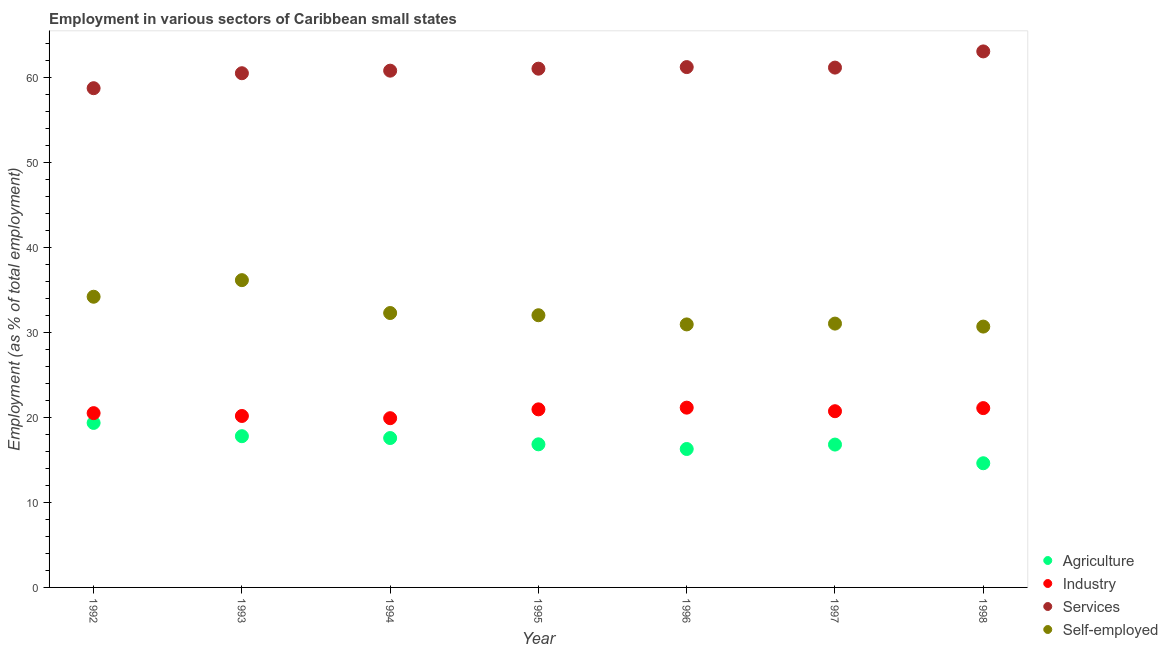How many different coloured dotlines are there?
Ensure brevity in your answer.  4. What is the percentage of workers in services in 1992?
Give a very brief answer. 58.79. Across all years, what is the maximum percentage of workers in industry?
Offer a very short reply. 21.17. Across all years, what is the minimum percentage of self employed workers?
Give a very brief answer. 30.72. What is the total percentage of workers in industry in the graph?
Offer a very short reply. 144.65. What is the difference between the percentage of workers in agriculture in 1993 and that in 1995?
Your response must be concise. 0.96. What is the difference between the percentage of self employed workers in 1994 and the percentage of workers in industry in 1992?
Provide a short and direct response. 11.79. What is the average percentage of workers in services per year?
Keep it short and to the point. 60.98. In the year 1994, what is the difference between the percentage of self employed workers and percentage of workers in agriculture?
Your answer should be compact. 14.72. What is the ratio of the percentage of workers in services in 1992 to that in 1994?
Provide a short and direct response. 0.97. What is the difference between the highest and the second highest percentage of workers in services?
Your response must be concise. 1.85. What is the difference between the highest and the lowest percentage of workers in agriculture?
Offer a terse response. 4.75. In how many years, is the percentage of workers in services greater than the average percentage of workers in services taken over all years?
Provide a short and direct response. 4. Is the sum of the percentage of workers in agriculture in 1995 and 1998 greater than the maximum percentage of workers in industry across all years?
Your answer should be compact. Yes. Is it the case that in every year, the sum of the percentage of workers in services and percentage of workers in industry is greater than the sum of percentage of self employed workers and percentage of workers in agriculture?
Keep it short and to the point. No. Is it the case that in every year, the sum of the percentage of workers in agriculture and percentage of workers in industry is greater than the percentage of workers in services?
Keep it short and to the point. No. Does the percentage of workers in agriculture monotonically increase over the years?
Ensure brevity in your answer.  No. Is the percentage of workers in agriculture strictly greater than the percentage of workers in industry over the years?
Your answer should be compact. No. What is the difference between two consecutive major ticks on the Y-axis?
Offer a very short reply. 10. Does the graph contain grids?
Make the answer very short. No. How many legend labels are there?
Offer a terse response. 4. What is the title of the graph?
Your answer should be very brief. Employment in various sectors of Caribbean small states. Does "International Monetary Fund" appear as one of the legend labels in the graph?
Provide a succinct answer. No. What is the label or title of the Y-axis?
Ensure brevity in your answer.  Employment (as % of total employment). What is the Employment (as % of total employment) in Agriculture in 1992?
Offer a very short reply. 19.37. What is the Employment (as % of total employment) in Industry in 1992?
Provide a short and direct response. 20.52. What is the Employment (as % of total employment) in Services in 1992?
Give a very brief answer. 58.79. What is the Employment (as % of total employment) of Self-employed in 1992?
Your answer should be very brief. 34.23. What is the Employment (as % of total employment) of Agriculture in 1993?
Keep it short and to the point. 17.81. What is the Employment (as % of total employment) in Industry in 1993?
Provide a short and direct response. 20.19. What is the Employment (as % of total employment) of Services in 1993?
Provide a short and direct response. 60.55. What is the Employment (as % of total employment) in Self-employed in 1993?
Give a very brief answer. 36.19. What is the Employment (as % of total employment) in Agriculture in 1994?
Your answer should be compact. 17.59. What is the Employment (as % of total employment) of Industry in 1994?
Give a very brief answer. 19.93. What is the Employment (as % of total employment) in Services in 1994?
Offer a very short reply. 60.85. What is the Employment (as % of total employment) in Self-employed in 1994?
Make the answer very short. 32.31. What is the Employment (as % of total employment) of Agriculture in 1995?
Your answer should be very brief. 16.85. What is the Employment (as % of total employment) of Industry in 1995?
Offer a terse response. 20.97. What is the Employment (as % of total employment) of Services in 1995?
Provide a short and direct response. 61.09. What is the Employment (as % of total employment) of Self-employed in 1995?
Provide a short and direct response. 32.05. What is the Employment (as % of total employment) of Agriculture in 1996?
Provide a succinct answer. 16.3. What is the Employment (as % of total employment) in Industry in 1996?
Your answer should be compact. 21.17. What is the Employment (as % of total employment) of Services in 1996?
Provide a succinct answer. 61.27. What is the Employment (as % of total employment) of Self-employed in 1996?
Your answer should be compact. 30.97. What is the Employment (as % of total employment) of Agriculture in 1997?
Provide a succinct answer. 16.82. What is the Employment (as % of total employment) of Industry in 1997?
Offer a terse response. 20.75. What is the Employment (as % of total employment) in Services in 1997?
Ensure brevity in your answer.  61.22. What is the Employment (as % of total employment) of Self-employed in 1997?
Keep it short and to the point. 31.07. What is the Employment (as % of total employment) in Agriculture in 1998?
Provide a short and direct response. 14.62. What is the Employment (as % of total employment) of Industry in 1998?
Your answer should be compact. 21.12. What is the Employment (as % of total employment) in Services in 1998?
Your answer should be compact. 63.12. What is the Employment (as % of total employment) in Self-employed in 1998?
Your answer should be very brief. 30.72. Across all years, what is the maximum Employment (as % of total employment) in Agriculture?
Make the answer very short. 19.37. Across all years, what is the maximum Employment (as % of total employment) in Industry?
Your answer should be very brief. 21.17. Across all years, what is the maximum Employment (as % of total employment) in Services?
Your answer should be compact. 63.12. Across all years, what is the maximum Employment (as % of total employment) of Self-employed?
Keep it short and to the point. 36.19. Across all years, what is the minimum Employment (as % of total employment) of Agriculture?
Offer a terse response. 14.62. Across all years, what is the minimum Employment (as % of total employment) of Industry?
Ensure brevity in your answer.  19.93. Across all years, what is the minimum Employment (as % of total employment) in Services?
Your answer should be very brief. 58.79. Across all years, what is the minimum Employment (as % of total employment) in Self-employed?
Your answer should be very brief. 30.72. What is the total Employment (as % of total employment) in Agriculture in the graph?
Make the answer very short. 119.38. What is the total Employment (as % of total employment) of Industry in the graph?
Provide a succinct answer. 144.65. What is the total Employment (as % of total employment) in Services in the graph?
Provide a succinct answer. 426.89. What is the total Employment (as % of total employment) in Self-employed in the graph?
Provide a succinct answer. 227.54. What is the difference between the Employment (as % of total employment) in Agriculture in 1992 and that in 1993?
Your answer should be very brief. 1.56. What is the difference between the Employment (as % of total employment) in Industry in 1992 and that in 1993?
Provide a short and direct response. 0.33. What is the difference between the Employment (as % of total employment) in Services in 1992 and that in 1993?
Your answer should be very brief. -1.76. What is the difference between the Employment (as % of total employment) in Self-employed in 1992 and that in 1993?
Your answer should be compact. -1.95. What is the difference between the Employment (as % of total employment) in Agriculture in 1992 and that in 1994?
Offer a very short reply. 1.78. What is the difference between the Employment (as % of total employment) of Industry in 1992 and that in 1994?
Keep it short and to the point. 0.59. What is the difference between the Employment (as % of total employment) in Services in 1992 and that in 1994?
Provide a short and direct response. -2.06. What is the difference between the Employment (as % of total employment) of Self-employed in 1992 and that in 1994?
Give a very brief answer. 1.92. What is the difference between the Employment (as % of total employment) in Agriculture in 1992 and that in 1995?
Provide a short and direct response. 2.52. What is the difference between the Employment (as % of total employment) in Industry in 1992 and that in 1995?
Your response must be concise. -0.45. What is the difference between the Employment (as % of total employment) in Services in 1992 and that in 1995?
Provide a short and direct response. -2.3. What is the difference between the Employment (as % of total employment) in Self-employed in 1992 and that in 1995?
Give a very brief answer. 2.18. What is the difference between the Employment (as % of total employment) of Agriculture in 1992 and that in 1996?
Provide a succinct answer. 3.07. What is the difference between the Employment (as % of total employment) in Industry in 1992 and that in 1996?
Make the answer very short. -0.65. What is the difference between the Employment (as % of total employment) in Services in 1992 and that in 1996?
Provide a succinct answer. -2.48. What is the difference between the Employment (as % of total employment) in Self-employed in 1992 and that in 1996?
Offer a very short reply. 3.26. What is the difference between the Employment (as % of total employment) of Agriculture in 1992 and that in 1997?
Your answer should be compact. 2.55. What is the difference between the Employment (as % of total employment) of Industry in 1992 and that in 1997?
Provide a succinct answer. -0.23. What is the difference between the Employment (as % of total employment) in Services in 1992 and that in 1997?
Make the answer very short. -2.43. What is the difference between the Employment (as % of total employment) in Self-employed in 1992 and that in 1997?
Make the answer very short. 3.16. What is the difference between the Employment (as % of total employment) of Agriculture in 1992 and that in 1998?
Your answer should be compact. 4.75. What is the difference between the Employment (as % of total employment) in Industry in 1992 and that in 1998?
Keep it short and to the point. -0.59. What is the difference between the Employment (as % of total employment) in Services in 1992 and that in 1998?
Your answer should be very brief. -4.33. What is the difference between the Employment (as % of total employment) of Self-employed in 1992 and that in 1998?
Provide a short and direct response. 3.51. What is the difference between the Employment (as % of total employment) of Agriculture in 1993 and that in 1994?
Ensure brevity in your answer.  0.22. What is the difference between the Employment (as % of total employment) of Industry in 1993 and that in 1994?
Provide a short and direct response. 0.26. What is the difference between the Employment (as % of total employment) in Services in 1993 and that in 1994?
Ensure brevity in your answer.  -0.3. What is the difference between the Employment (as % of total employment) of Self-employed in 1993 and that in 1994?
Keep it short and to the point. 3.87. What is the difference between the Employment (as % of total employment) in Agriculture in 1993 and that in 1995?
Ensure brevity in your answer.  0.96. What is the difference between the Employment (as % of total employment) of Industry in 1993 and that in 1995?
Your answer should be compact. -0.78. What is the difference between the Employment (as % of total employment) in Services in 1993 and that in 1995?
Keep it short and to the point. -0.54. What is the difference between the Employment (as % of total employment) of Self-employed in 1993 and that in 1995?
Your answer should be very brief. 4.13. What is the difference between the Employment (as % of total employment) of Agriculture in 1993 and that in 1996?
Provide a succinct answer. 1.51. What is the difference between the Employment (as % of total employment) in Industry in 1993 and that in 1996?
Provide a short and direct response. -0.98. What is the difference between the Employment (as % of total employment) in Services in 1993 and that in 1996?
Ensure brevity in your answer.  -0.72. What is the difference between the Employment (as % of total employment) in Self-employed in 1993 and that in 1996?
Keep it short and to the point. 5.21. What is the difference between the Employment (as % of total employment) in Agriculture in 1993 and that in 1997?
Give a very brief answer. 0.99. What is the difference between the Employment (as % of total employment) in Industry in 1993 and that in 1997?
Ensure brevity in your answer.  -0.56. What is the difference between the Employment (as % of total employment) in Services in 1993 and that in 1997?
Make the answer very short. -0.66. What is the difference between the Employment (as % of total employment) of Self-employed in 1993 and that in 1997?
Your answer should be very brief. 5.12. What is the difference between the Employment (as % of total employment) of Agriculture in 1993 and that in 1998?
Keep it short and to the point. 3.19. What is the difference between the Employment (as % of total employment) of Industry in 1993 and that in 1998?
Provide a succinct answer. -0.93. What is the difference between the Employment (as % of total employment) in Services in 1993 and that in 1998?
Your answer should be very brief. -2.57. What is the difference between the Employment (as % of total employment) in Self-employed in 1993 and that in 1998?
Give a very brief answer. 5.47. What is the difference between the Employment (as % of total employment) in Agriculture in 1994 and that in 1995?
Keep it short and to the point. 0.74. What is the difference between the Employment (as % of total employment) of Industry in 1994 and that in 1995?
Offer a terse response. -1.04. What is the difference between the Employment (as % of total employment) of Services in 1994 and that in 1995?
Give a very brief answer. -0.23. What is the difference between the Employment (as % of total employment) in Self-employed in 1994 and that in 1995?
Offer a very short reply. 0.26. What is the difference between the Employment (as % of total employment) of Agriculture in 1994 and that in 1996?
Ensure brevity in your answer.  1.29. What is the difference between the Employment (as % of total employment) in Industry in 1994 and that in 1996?
Your answer should be very brief. -1.24. What is the difference between the Employment (as % of total employment) in Services in 1994 and that in 1996?
Your response must be concise. -0.42. What is the difference between the Employment (as % of total employment) in Self-employed in 1994 and that in 1996?
Provide a succinct answer. 1.34. What is the difference between the Employment (as % of total employment) of Agriculture in 1994 and that in 1997?
Your answer should be compact. 0.77. What is the difference between the Employment (as % of total employment) in Industry in 1994 and that in 1997?
Keep it short and to the point. -0.82. What is the difference between the Employment (as % of total employment) of Services in 1994 and that in 1997?
Offer a terse response. -0.36. What is the difference between the Employment (as % of total employment) in Self-employed in 1994 and that in 1997?
Make the answer very short. 1.25. What is the difference between the Employment (as % of total employment) in Agriculture in 1994 and that in 1998?
Offer a very short reply. 2.97. What is the difference between the Employment (as % of total employment) of Industry in 1994 and that in 1998?
Your answer should be very brief. -1.19. What is the difference between the Employment (as % of total employment) in Services in 1994 and that in 1998?
Provide a succinct answer. -2.27. What is the difference between the Employment (as % of total employment) of Self-employed in 1994 and that in 1998?
Offer a terse response. 1.6. What is the difference between the Employment (as % of total employment) of Agriculture in 1995 and that in 1996?
Ensure brevity in your answer.  0.55. What is the difference between the Employment (as % of total employment) of Industry in 1995 and that in 1996?
Your answer should be compact. -0.2. What is the difference between the Employment (as % of total employment) of Services in 1995 and that in 1996?
Give a very brief answer. -0.19. What is the difference between the Employment (as % of total employment) of Self-employed in 1995 and that in 1996?
Provide a succinct answer. 1.08. What is the difference between the Employment (as % of total employment) in Agriculture in 1995 and that in 1997?
Provide a succinct answer. 0.03. What is the difference between the Employment (as % of total employment) in Industry in 1995 and that in 1997?
Your response must be concise. 0.22. What is the difference between the Employment (as % of total employment) of Services in 1995 and that in 1997?
Your answer should be very brief. -0.13. What is the difference between the Employment (as % of total employment) of Self-employed in 1995 and that in 1997?
Offer a terse response. 0.98. What is the difference between the Employment (as % of total employment) of Agriculture in 1995 and that in 1998?
Make the answer very short. 2.23. What is the difference between the Employment (as % of total employment) of Industry in 1995 and that in 1998?
Give a very brief answer. -0.15. What is the difference between the Employment (as % of total employment) in Services in 1995 and that in 1998?
Your answer should be very brief. -2.03. What is the difference between the Employment (as % of total employment) in Self-employed in 1995 and that in 1998?
Offer a very short reply. 1.34. What is the difference between the Employment (as % of total employment) of Agriculture in 1996 and that in 1997?
Provide a short and direct response. -0.52. What is the difference between the Employment (as % of total employment) in Industry in 1996 and that in 1997?
Make the answer very short. 0.42. What is the difference between the Employment (as % of total employment) of Services in 1996 and that in 1997?
Provide a short and direct response. 0.06. What is the difference between the Employment (as % of total employment) of Self-employed in 1996 and that in 1997?
Offer a terse response. -0.1. What is the difference between the Employment (as % of total employment) in Agriculture in 1996 and that in 1998?
Make the answer very short. 1.68. What is the difference between the Employment (as % of total employment) in Industry in 1996 and that in 1998?
Offer a very short reply. 0.05. What is the difference between the Employment (as % of total employment) in Services in 1996 and that in 1998?
Your answer should be compact. -1.85. What is the difference between the Employment (as % of total employment) of Self-employed in 1996 and that in 1998?
Your answer should be compact. 0.26. What is the difference between the Employment (as % of total employment) of Agriculture in 1997 and that in 1998?
Provide a short and direct response. 2.2. What is the difference between the Employment (as % of total employment) in Industry in 1997 and that in 1998?
Your response must be concise. -0.37. What is the difference between the Employment (as % of total employment) in Services in 1997 and that in 1998?
Your answer should be very brief. -1.91. What is the difference between the Employment (as % of total employment) of Self-employed in 1997 and that in 1998?
Offer a very short reply. 0.35. What is the difference between the Employment (as % of total employment) of Agriculture in 1992 and the Employment (as % of total employment) of Industry in 1993?
Make the answer very short. -0.82. What is the difference between the Employment (as % of total employment) in Agriculture in 1992 and the Employment (as % of total employment) in Services in 1993?
Offer a very short reply. -41.18. What is the difference between the Employment (as % of total employment) in Agriculture in 1992 and the Employment (as % of total employment) in Self-employed in 1993?
Provide a succinct answer. -16.81. What is the difference between the Employment (as % of total employment) of Industry in 1992 and the Employment (as % of total employment) of Services in 1993?
Provide a short and direct response. -40.03. What is the difference between the Employment (as % of total employment) of Industry in 1992 and the Employment (as % of total employment) of Self-employed in 1993?
Give a very brief answer. -15.66. What is the difference between the Employment (as % of total employment) in Services in 1992 and the Employment (as % of total employment) in Self-employed in 1993?
Offer a terse response. 22.61. What is the difference between the Employment (as % of total employment) of Agriculture in 1992 and the Employment (as % of total employment) of Industry in 1994?
Keep it short and to the point. -0.56. What is the difference between the Employment (as % of total employment) of Agriculture in 1992 and the Employment (as % of total employment) of Services in 1994?
Provide a succinct answer. -41.48. What is the difference between the Employment (as % of total employment) in Agriculture in 1992 and the Employment (as % of total employment) in Self-employed in 1994?
Your response must be concise. -12.94. What is the difference between the Employment (as % of total employment) of Industry in 1992 and the Employment (as % of total employment) of Services in 1994?
Provide a succinct answer. -40.33. What is the difference between the Employment (as % of total employment) in Industry in 1992 and the Employment (as % of total employment) in Self-employed in 1994?
Offer a terse response. -11.79. What is the difference between the Employment (as % of total employment) of Services in 1992 and the Employment (as % of total employment) of Self-employed in 1994?
Keep it short and to the point. 26.48. What is the difference between the Employment (as % of total employment) of Agriculture in 1992 and the Employment (as % of total employment) of Industry in 1995?
Your answer should be compact. -1.6. What is the difference between the Employment (as % of total employment) in Agriculture in 1992 and the Employment (as % of total employment) in Services in 1995?
Provide a short and direct response. -41.71. What is the difference between the Employment (as % of total employment) in Agriculture in 1992 and the Employment (as % of total employment) in Self-employed in 1995?
Your answer should be very brief. -12.68. What is the difference between the Employment (as % of total employment) of Industry in 1992 and the Employment (as % of total employment) of Services in 1995?
Make the answer very short. -40.56. What is the difference between the Employment (as % of total employment) in Industry in 1992 and the Employment (as % of total employment) in Self-employed in 1995?
Provide a short and direct response. -11.53. What is the difference between the Employment (as % of total employment) in Services in 1992 and the Employment (as % of total employment) in Self-employed in 1995?
Provide a short and direct response. 26.74. What is the difference between the Employment (as % of total employment) of Agriculture in 1992 and the Employment (as % of total employment) of Industry in 1996?
Provide a short and direct response. -1.8. What is the difference between the Employment (as % of total employment) in Agriculture in 1992 and the Employment (as % of total employment) in Services in 1996?
Provide a short and direct response. -41.9. What is the difference between the Employment (as % of total employment) of Agriculture in 1992 and the Employment (as % of total employment) of Self-employed in 1996?
Your response must be concise. -11.6. What is the difference between the Employment (as % of total employment) in Industry in 1992 and the Employment (as % of total employment) in Services in 1996?
Your answer should be very brief. -40.75. What is the difference between the Employment (as % of total employment) in Industry in 1992 and the Employment (as % of total employment) in Self-employed in 1996?
Provide a short and direct response. -10.45. What is the difference between the Employment (as % of total employment) in Services in 1992 and the Employment (as % of total employment) in Self-employed in 1996?
Give a very brief answer. 27.82. What is the difference between the Employment (as % of total employment) in Agriculture in 1992 and the Employment (as % of total employment) in Industry in 1997?
Give a very brief answer. -1.38. What is the difference between the Employment (as % of total employment) in Agriculture in 1992 and the Employment (as % of total employment) in Services in 1997?
Your answer should be very brief. -41.84. What is the difference between the Employment (as % of total employment) of Agriculture in 1992 and the Employment (as % of total employment) of Self-employed in 1997?
Your answer should be very brief. -11.69. What is the difference between the Employment (as % of total employment) in Industry in 1992 and the Employment (as % of total employment) in Services in 1997?
Ensure brevity in your answer.  -40.69. What is the difference between the Employment (as % of total employment) of Industry in 1992 and the Employment (as % of total employment) of Self-employed in 1997?
Provide a succinct answer. -10.54. What is the difference between the Employment (as % of total employment) of Services in 1992 and the Employment (as % of total employment) of Self-employed in 1997?
Provide a short and direct response. 27.72. What is the difference between the Employment (as % of total employment) in Agriculture in 1992 and the Employment (as % of total employment) in Industry in 1998?
Keep it short and to the point. -1.74. What is the difference between the Employment (as % of total employment) of Agriculture in 1992 and the Employment (as % of total employment) of Services in 1998?
Offer a terse response. -43.75. What is the difference between the Employment (as % of total employment) in Agriculture in 1992 and the Employment (as % of total employment) in Self-employed in 1998?
Keep it short and to the point. -11.34. What is the difference between the Employment (as % of total employment) of Industry in 1992 and the Employment (as % of total employment) of Services in 1998?
Keep it short and to the point. -42.6. What is the difference between the Employment (as % of total employment) of Industry in 1992 and the Employment (as % of total employment) of Self-employed in 1998?
Your answer should be compact. -10.19. What is the difference between the Employment (as % of total employment) in Services in 1992 and the Employment (as % of total employment) in Self-employed in 1998?
Keep it short and to the point. 28.07. What is the difference between the Employment (as % of total employment) in Agriculture in 1993 and the Employment (as % of total employment) in Industry in 1994?
Your response must be concise. -2.12. What is the difference between the Employment (as % of total employment) of Agriculture in 1993 and the Employment (as % of total employment) of Services in 1994?
Your answer should be very brief. -43.04. What is the difference between the Employment (as % of total employment) of Agriculture in 1993 and the Employment (as % of total employment) of Self-employed in 1994?
Your answer should be compact. -14.5. What is the difference between the Employment (as % of total employment) in Industry in 1993 and the Employment (as % of total employment) in Services in 1994?
Offer a terse response. -40.66. What is the difference between the Employment (as % of total employment) in Industry in 1993 and the Employment (as % of total employment) in Self-employed in 1994?
Your answer should be very brief. -12.12. What is the difference between the Employment (as % of total employment) of Services in 1993 and the Employment (as % of total employment) of Self-employed in 1994?
Provide a short and direct response. 28.24. What is the difference between the Employment (as % of total employment) of Agriculture in 1993 and the Employment (as % of total employment) of Industry in 1995?
Your response must be concise. -3.16. What is the difference between the Employment (as % of total employment) of Agriculture in 1993 and the Employment (as % of total employment) of Services in 1995?
Ensure brevity in your answer.  -43.28. What is the difference between the Employment (as % of total employment) of Agriculture in 1993 and the Employment (as % of total employment) of Self-employed in 1995?
Your answer should be very brief. -14.24. What is the difference between the Employment (as % of total employment) of Industry in 1993 and the Employment (as % of total employment) of Services in 1995?
Your answer should be compact. -40.9. What is the difference between the Employment (as % of total employment) of Industry in 1993 and the Employment (as % of total employment) of Self-employed in 1995?
Offer a very short reply. -11.86. What is the difference between the Employment (as % of total employment) in Services in 1993 and the Employment (as % of total employment) in Self-employed in 1995?
Your answer should be very brief. 28.5. What is the difference between the Employment (as % of total employment) of Agriculture in 1993 and the Employment (as % of total employment) of Industry in 1996?
Your answer should be compact. -3.36. What is the difference between the Employment (as % of total employment) in Agriculture in 1993 and the Employment (as % of total employment) in Services in 1996?
Keep it short and to the point. -43.47. What is the difference between the Employment (as % of total employment) in Agriculture in 1993 and the Employment (as % of total employment) in Self-employed in 1996?
Offer a terse response. -13.16. What is the difference between the Employment (as % of total employment) of Industry in 1993 and the Employment (as % of total employment) of Services in 1996?
Keep it short and to the point. -41.08. What is the difference between the Employment (as % of total employment) in Industry in 1993 and the Employment (as % of total employment) in Self-employed in 1996?
Your answer should be compact. -10.78. What is the difference between the Employment (as % of total employment) of Services in 1993 and the Employment (as % of total employment) of Self-employed in 1996?
Provide a succinct answer. 29.58. What is the difference between the Employment (as % of total employment) in Agriculture in 1993 and the Employment (as % of total employment) in Industry in 1997?
Provide a short and direct response. -2.94. What is the difference between the Employment (as % of total employment) of Agriculture in 1993 and the Employment (as % of total employment) of Services in 1997?
Your response must be concise. -43.41. What is the difference between the Employment (as % of total employment) in Agriculture in 1993 and the Employment (as % of total employment) in Self-employed in 1997?
Your response must be concise. -13.26. What is the difference between the Employment (as % of total employment) of Industry in 1993 and the Employment (as % of total employment) of Services in 1997?
Offer a terse response. -41.02. What is the difference between the Employment (as % of total employment) of Industry in 1993 and the Employment (as % of total employment) of Self-employed in 1997?
Offer a very short reply. -10.88. What is the difference between the Employment (as % of total employment) of Services in 1993 and the Employment (as % of total employment) of Self-employed in 1997?
Your response must be concise. 29.48. What is the difference between the Employment (as % of total employment) of Agriculture in 1993 and the Employment (as % of total employment) of Industry in 1998?
Offer a very short reply. -3.31. What is the difference between the Employment (as % of total employment) in Agriculture in 1993 and the Employment (as % of total employment) in Services in 1998?
Give a very brief answer. -45.31. What is the difference between the Employment (as % of total employment) of Agriculture in 1993 and the Employment (as % of total employment) of Self-employed in 1998?
Your answer should be compact. -12.91. What is the difference between the Employment (as % of total employment) of Industry in 1993 and the Employment (as % of total employment) of Services in 1998?
Make the answer very short. -42.93. What is the difference between the Employment (as % of total employment) in Industry in 1993 and the Employment (as % of total employment) in Self-employed in 1998?
Ensure brevity in your answer.  -10.53. What is the difference between the Employment (as % of total employment) in Services in 1993 and the Employment (as % of total employment) in Self-employed in 1998?
Your response must be concise. 29.84. What is the difference between the Employment (as % of total employment) of Agriculture in 1994 and the Employment (as % of total employment) of Industry in 1995?
Your answer should be very brief. -3.38. What is the difference between the Employment (as % of total employment) in Agriculture in 1994 and the Employment (as % of total employment) in Services in 1995?
Provide a short and direct response. -43.5. What is the difference between the Employment (as % of total employment) of Agriculture in 1994 and the Employment (as % of total employment) of Self-employed in 1995?
Keep it short and to the point. -14.46. What is the difference between the Employment (as % of total employment) in Industry in 1994 and the Employment (as % of total employment) in Services in 1995?
Offer a terse response. -41.16. What is the difference between the Employment (as % of total employment) in Industry in 1994 and the Employment (as % of total employment) in Self-employed in 1995?
Your response must be concise. -12.12. What is the difference between the Employment (as % of total employment) in Services in 1994 and the Employment (as % of total employment) in Self-employed in 1995?
Offer a very short reply. 28.8. What is the difference between the Employment (as % of total employment) of Agriculture in 1994 and the Employment (as % of total employment) of Industry in 1996?
Your response must be concise. -3.58. What is the difference between the Employment (as % of total employment) in Agriculture in 1994 and the Employment (as % of total employment) in Services in 1996?
Your answer should be very brief. -43.68. What is the difference between the Employment (as % of total employment) in Agriculture in 1994 and the Employment (as % of total employment) in Self-employed in 1996?
Offer a terse response. -13.38. What is the difference between the Employment (as % of total employment) in Industry in 1994 and the Employment (as % of total employment) in Services in 1996?
Provide a short and direct response. -41.35. What is the difference between the Employment (as % of total employment) in Industry in 1994 and the Employment (as % of total employment) in Self-employed in 1996?
Give a very brief answer. -11.04. What is the difference between the Employment (as % of total employment) of Services in 1994 and the Employment (as % of total employment) of Self-employed in 1996?
Give a very brief answer. 29.88. What is the difference between the Employment (as % of total employment) in Agriculture in 1994 and the Employment (as % of total employment) in Industry in 1997?
Keep it short and to the point. -3.16. What is the difference between the Employment (as % of total employment) in Agriculture in 1994 and the Employment (as % of total employment) in Services in 1997?
Your answer should be compact. -43.62. What is the difference between the Employment (as % of total employment) of Agriculture in 1994 and the Employment (as % of total employment) of Self-employed in 1997?
Keep it short and to the point. -13.48. What is the difference between the Employment (as % of total employment) in Industry in 1994 and the Employment (as % of total employment) in Services in 1997?
Give a very brief answer. -41.29. What is the difference between the Employment (as % of total employment) in Industry in 1994 and the Employment (as % of total employment) in Self-employed in 1997?
Your answer should be compact. -11.14. What is the difference between the Employment (as % of total employment) of Services in 1994 and the Employment (as % of total employment) of Self-employed in 1997?
Provide a succinct answer. 29.78. What is the difference between the Employment (as % of total employment) of Agriculture in 1994 and the Employment (as % of total employment) of Industry in 1998?
Offer a terse response. -3.53. What is the difference between the Employment (as % of total employment) of Agriculture in 1994 and the Employment (as % of total employment) of Services in 1998?
Your response must be concise. -45.53. What is the difference between the Employment (as % of total employment) of Agriculture in 1994 and the Employment (as % of total employment) of Self-employed in 1998?
Ensure brevity in your answer.  -13.13. What is the difference between the Employment (as % of total employment) of Industry in 1994 and the Employment (as % of total employment) of Services in 1998?
Keep it short and to the point. -43.19. What is the difference between the Employment (as % of total employment) of Industry in 1994 and the Employment (as % of total employment) of Self-employed in 1998?
Offer a terse response. -10.79. What is the difference between the Employment (as % of total employment) of Services in 1994 and the Employment (as % of total employment) of Self-employed in 1998?
Offer a very short reply. 30.14. What is the difference between the Employment (as % of total employment) in Agriculture in 1995 and the Employment (as % of total employment) in Industry in 1996?
Your answer should be compact. -4.32. What is the difference between the Employment (as % of total employment) in Agriculture in 1995 and the Employment (as % of total employment) in Services in 1996?
Give a very brief answer. -44.42. What is the difference between the Employment (as % of total employment) of Agriculture in 1995 and the Employment (as % of total employment) of Self-employed in 1996?
Your answer should be very brief. -14.12. What is the difference between the Employment (as % of total employment) in Industry in 1995 and the Employment (as % of total employment) in Services in 1996?
Make the answer very short. -40.31. What is the difference between the Employment (as % of total employment) in Industry in 1995 and the Employment (as % of total employment) in Self-employed in 1996?
Ensure brevity in your answer.  -10. What is the difference between the Employment (as % of total employment) of Services in 1995 and the Employment (as % of total employment) of Self-employed in 1996?
Offer a very short reply. 30.12. What is the difference between the Employment (as % of total employment) in Agriculture in 1995 and the Employment (as % of total employment) in Industry in 1997?
Ensure brevity in your answer.  -3.9. What is the difference between the Employment (as % of total employment) of Agriculture in 1995 and the Employment (as % of total employment) of Services in 1997?
Your response must be concise. -44.36. What is the difference between the Employment (as % of total employment) in Agriculture in 1995 and the Employment (as % of total employment) in Self-employed in 1997?
Provide a short and direct response. -14.22. What is the difference between the Employment (as % of total employment) of Industry in 1995 and the Employment (as % of total employment) of Services in 1997?
Offer a terse response. -40.25. What is the difference between the Employment (as % of total employment) in Industry in 1995 and the Employment (as % of total employment) in Self-employed in 1997?
Give a very brief answer. -10.1. What is the difference between the Employment (as % of total employment) of Services in 1995 and the Employment (as % of total employment) of Self-employed in 1997?
Your answer should be very brief. 30.02. What is the difference between the Employment (as % of total employment) of Agriculture in 1995 and the Employment (as % of total employment) of Industry in 1998?
Provide a succinct answer. -4.26. What is the difference between the Employment (as % of total employment) of Agriculture in 1995 and the Employment (as % of total employment) of Services in 1998?
Your answer should be compact. -46.27. What is the difference between the Employment (as % of total employment) in Agriculture in 1995 and the Employment (as % of total employment) in Self-employed in 1998?
Give a very brief answer. -13.86. What is the difference between the Employment (as % of total employment) of Industry in 1995 and the Employment (as % of total employment) of Services in 1998?
Make the answer very short. -42.15. What is the difference between the Employment (as % of total employment) of Industry in 1995 and the Employment (as % of total employment) of Self-employed in 1998?
Provide a short and direct response. -9.75. What is the difference between the Employment (as % of total employment) in Services in 1995 and the Employment (as % of total employment) in Self-employed in 1998?
Your answer should be compact. 30.37. What is the difference between the Employment (as % of total employment) of Agriculture in 1996 and the Employment (as % of total employment) of Industry in 1997?
Make the answer very short. -4.45. What is the difference between the Employment (as % of total employment) of Agriculture in 1996 and the Employment (as % of total employment) of Services in 1997?
Your response must be concise. -44.91. What is the difference between the Employment (as % of total employment) of Agriculture in 1996 and the Employment (as % of total employment) of Self-employed in 1997?
Offer a terse response. -14.77. What is the difference between the Employment (as % of total employment) of Industry in 1996 and the Employment (as % of total employment) of Services in 1997?
Your answer should be compact. -40.04. What is the difference between the Employment (as % of total employment) of Industry in 1996 and the Employment (as % of total employment) of Self-employed in 1997?
Provide a short and direct response. -9.9. What is the difference between the Employment (as % of total employment) of Services in 1996 and the Employment (as % of total employment) of Self-employed in 1997?
Ensure brevity in your answer.  30.21. What is the difference between the Employment (as % of total employment) of Agriculture in 1996 and the Employment (as % of total employment) of Industry in 1998?
Give a very brief answer. -4.82. What is the difference between the Employment (as % of total employment) of Agriculture in 1996 and the Employment (as % of total employment) of Services in 1998?
Offer a terse response. -46.82. What is the difference between the Employment (as % of total employment) in Agriculture in 1996 and the Employment (as % of total employment) in Self-employed in 1998?
Keep it short and to the point. -14.42. What is the difference between the Employment (as % of total employment) in Industry in 1996 and the Employment (as % of total employment) in Services in 1998?
Keep it short and to the point. -41.95. What is the difference between the Employment (as % of total employment) of Industry in 1996 and the Employment (as % of total employment) of Self-employed in 1998?
Your answer should be compact. -9.55. What is the difference between the Employment (as % of total employment) in Services in 1996 and the Employment (as % of total employment) in Self-employed in 1998?
Offer a terse response. 30.56. What is the difference between the Employment (as % of total employment) in Agriculture in 1997 and the Employment (as % of total employment) in Industry in 1998?
Offer a very short reply. -4.29. What is the difference between the Employment (as % of total employment) in Agriculture in 1997 and the Employment (as % of total employment) in Services in 1998?
Provide a succinct answer. -46.3. What is the difference between the Employment (as % of total employment) of Agriculture in 1997 and the Employment (as % of total employment) of Self-employed in 1998?
Offer a very short reply. -13.89. What is the difference between the Employment (as % of total employment) in Industry in 1997 and the Employment (as % of total employment) in Services in 1998?
Offer a very short reply. -42.37. What is the difference between the Employment (as % of total employment) in Industry in 1997 and the Employment (as % of total employment) in Self-employed in 1998?
Provide a succinct answer. -9.97. What is the difference between the Employment (as % of total employment) of Services in 1997 and the Employment (as % of total employment) of Self-employed in 1998?
Ensure brevity in your answer.  30.5. What is the average Employment (as % of total employment) in Agriculture per year?
Offer a terse response. 17.05. What is the average Employment (as % of total employment) of Industry per year?
Provide a short and direct response. 20.66. What is the average Employment (as % of total employment) of Services per year?
Your answer should be compact. 60.98. What is the average Employment (as % of total employment) in Self-employed per year?
Make the answer very short. 32.51. In the year 1992, what is the difference between the Employment (as % of total employment) of Agriculture and Employment (as % of total employment) of Industry?
Keep it short and to the point. -1.15. In the year 1992, what is the difference between the Employment (as % of total employment) in Agriculture and Employment (as % of total employment) in Services?
Offer a very short reply. -39.42. In the year 1992, what is the difference between the Employment (as % of total employment) in Agriculture and Employment (as % of total employment) in Self-employed?
Your answer should be compact. -14.86. In the year 1992, what is the difference between the Employment (as % of total employment) of Industry and Employment (as % of total employment) of Services?
Offer a terse response. -38.27. In the year 1992, what is the difference between the Employment (as % of total employment) in Industry and Employment (as % of total employment) in Self-employed?
Keep it short and to the point. -13.71. In the year 1992, what is the difference between the Employment (as % of total employment) in Services and Employment (as % of total employment) in Self-employed?
Offer a very short reply. 24.56. In the year 1993, what is the difference between the Employment (as % of total employment) in Agriculture and Employment (as % of total employment) in Industry?
Provide a short and direct response. -2.38. In the year 1993, what is the difference between the Employment (as % of total employment) in Agriculture and Employment (as % of total employment) in Services?
Keep it short and to the point. -42.74. In the year 1993, what is the difference between the Employment (as % of total employment) of Agriculture and Employment (as % of total employment) of Self-employed?
Keep it short and to the point. -18.38. In the year 1993, what is the difference between the Employment (as % of total employment) in Industry and Employment (as % of total employment) in Services?
Offer a terse response. -40.36. In the year 1993, what is the difference between the Employment (as % of total employment) in Industry and Employment (as % of total employment) in Self-employed?
Keep it short and to the point. -15.99. In the year 1993, what is the difference between the Employment (as % of total employment) in Services and Employment (as % of total employment) in Self-employed?
Give a very brief answer. 24.37. In the year 1994, what is the difference between the Employment (as % of total employment) in Agriculture and Employment (as % of total employment) in Industry?
Make the answer very short. -2.34. In the year 1994, what is the difference between the Employment (as % of total employment) in Agriculture and Employment (as % of total employment) in Services?
Ensure brevity in your answer.  -43.26. In the year 1994, what is the difference between the Employment (as % of total employment) in Agriculture and Employment (as % of total employment) in Self-employed?
Your answer should be very brief. -14.72. In the year 1994, what is the difference between the Employment (as % of total employment) in Industry and Employment (as % of total employment) in Services?
Give a very brief answer. -40.92. In the year 1994, what is the difference between the Employment (as % of total employment) of Industry and Employment (as % of total employment) of Self-employed?
Ensure brevity in your answer.  -12.39. In the year 1994, what is the difference between the Employment (as % of total employment) in Services and Employment (as % of total employment) in Self-employed?
Your response must be concise. 28.54. In the year 1995, what is the difference between the Employment (as % of total employment) of Agriculture and Employment (as % of total employment) of Industry?
Give a very brief answer. -4.12. In the year 1995, what is the difference between the Employment (as % of total employment) of Agriculture and Employment (as % of total employment) of Services?
Keep it short and to the point. -44.24. In the year 1995, what is the difference between the Employment (as % of total employment) in Agriculture and Employment (as % of total employment) in Self-employed?
Your answer should be compact. -15.2. In the year 1995, what is the difference between the Employment (as % of total employment) of Industry and Employment (as % of total employment) of Services?
Offer a terse response. -40.12. In the year 1995, what is the difference between the Employment (as % of total employment) of Industry and Employment (as % of total employment) of Self-employed?
Your response must be concise. -11.08. In the year 1995, what is the difference between the Employment (as % of total employment) in Services and Employment (as % of total employment) in Self-employed?
Provide a succinct answer. 29.04. In the year 1996, what is the difference between the Employment (as % of total employment) of Agriculture and Employment (as % of total employment) of Industry?
Offer a very short reply. -4.87. In the year 1996, what is the difference between the Employment (as % of total employment) in Agriculture and Employment (as % of total employment) in Services?
Your response must be concise. -44.97. In the year 1996, what is the difference between the Employment (as % of total employment) of Agriculture and Employment (as % of total employment) of Self-employed?
Give a very brief answer. -14.67. In the year 1996, what is the difference between the Employment (as % of total employment) in Industry and Employment (as % of total employment) in Services?
Offer a terse response. -40.1. In the year 1996, what is the difference between the Employment (as % of total employment) of Industry and Employment (as % of total employment) of Self-employed?
Your answer should be very brief. -9.8. In the year 1996, what is the difference between the Employment (as % of total employment) in Services and Employment (as % of total employment) in Self-employed?
Your answer should be very brief. 30.3. In the year 1997, what is the difference between the Employment (as % of total employment) of Agriculture and Employment (as % of total employment) of Industry?
Keep it short and to the point. -3.93. In the year 1997, what is the difference between the Employment (as % of total employment) of Agriculture and Employment (as % of total employment) of Services?
Provide a succinct answer. -44.39. In the year 1997, what is the difference between the Employment (as % of total employment) in Agriculture and Employment (as % of total employment) in Self-employed?
Offer a very short reply. -14.25. In the year 1997, what is the difference between the Employment (as % of total employment) in Industry and Employment (as % of total employment) in Services?
Your answer should be compact. -40.46. In the year 1997, what is the difference between the Employment (as % of total employment) of Industry and Employment (as % of total employment) of Self-employed?
Give a very brief answer. -10.32. In the year 1997, what is the difference between the Employment (as % of total employment) of Services and Employment (as % of total employment) of Self-employed?
Your answer should be compact. 30.15. In the year 1998, what is the difference between the Employment (as % of total employment) of Agriculture and Employment (as % of total employment) of Industry?
Keep it short and to the point. -6.49. In the year 1998, what is the difference between the Employment (as % of total employment) of Agriculture and Employment (as % of total employment) of Services?
Your answer should be very brief. -48.5. In the year 1998, what is the difference between the Employment (as % of total employment) in Agriculture and Employment (as % of total employment) in Self-employed?
Give a very brief answer. -16.09. In the year 1998, what is the difference between the Employment (as % of total employment) in Industry and Employment (as % of total employment) in Services?
Make the answer very short. -42. In the year 1998, what is the difference between the Employment (as % of total employment) in Industry and Employment (as % of total employment) in Self-employed?
Ensure brevity in your answer.  -9.6. In the year 1998, what is the difference between the Employment (as % of total employment) in Services and Employment (as % of total employment) in Self-employed?
Keep it short and to the point. 32.4. What is the ratio of the Employment (as % of total employment) in Agriculture in 1992 to that in 1993?
Offer a terse response. 1.09. What is the ratio of the Employment (as % of total employment) of Industry in 1992 to that in 1993?
Offer a very short reply. 1.02. What is the ratio of the Employment (as % of total employment) of Services in 1992 to that in 1993?
Offer a terse response. 0.97. What is the ratio of the Employment (as % of total employment) of Self-employed in 1992 to that in 1993?
Offer a terse response. 0.95. What is the ratio of the Employment (as % of total employment) in Agriculture in 1992 to that in 1994?
Make the answer very short. 1.1. What is the ratio of the Employment (as % of total employment) of Industry in 1992 to that in 1994?
Make the answer very short. 1.03. What is the ratio of the Employment (as % of total employment) of Services in 1992 to that in 1994?
Provide a short and direct response. 0.97. What is the ratio of the Employment (as % of total employment) of Self-employed in 1992 to that in 1994?
Provide a short and direct response. 1.06. What is the ratio of the Employment (as % of total employment) in Agriculture in 1992 to that in 1995?
Make the answer very short. 1.15. What is the ratio of the Employment (as % of total employment) in Industry in 1992 to that in 1995?
Offer a terse response. 0.98. What is the ratio of the Employment (as % of total employment) in Services in 1992 to that in 1995?
Keep it short and to the point. 0.96. What is the ratio of the Employment (as % of total employment) of Self-employed in 1992 to that in 1995?
Your answer should be compact. 1.07. What is the ratio of the Employment (as % of total employment) in Agriculture in 1992 to that in 1996?
Offer a very short reply. 1.19. What is the ratio of the Employment (as % of total employment) in Industry in 1992 to that in 1996?
Keep it short and to the point. 0.97. What is the ratio of the Employment (as % of total employment) in Services in 1992 to that in 1996?
Offer a terse response. 0.96. What is the ratio of the Employment (as % of total employment) of Self-employed in 1992 to that in 1996?
Keep it short and to the point. 1.11. What is the ratio of the Employment (as % of total employment) in Agriculture in 1992 to that in 1997?
Make the answer very short. 1.15. What is the ratio of the Employment (as % of total employment) in Services in 1992 to that in 1997?
Your response must be concise. 0.96. What is the ratio of the Employment (as % of total employment) of Self-employed in 1992 to that in 1997?
Your answer should be very brief. 1.1. What is the ratio of the Employment (as % of total employment) of Agriculture in 1992 to that in 1998?
Make the answer very short. 1.32. What is the ratio of the Employment (as % of total employment) of Industry in 1992 to that in 1998?
Provide a short and direct response. 0.97. What is the ratio of the Employment (as % of total employment) in Services in 1992 to that in 1998?
Your response must be concise. 0.93. What is the ratio of the Employment (as % of total employment) in Self-employed in 1992 to that in 1998?
Offer a terse response. 1.11. What is the ratio of the Employment (as % of total employment) in Agriculture in 1993 to that in 1994?
Provide a succinct answer. 1.01. What is the ratio of the Employment (as % of total employment) in Industry in 1993 to that in 1994?
Your answer should be compact. 1.01. What is the ratio of the Employment (as % of total employment) in Services in 1993 to that in 1994?
Offer a terse response. 0.99. What is the ratio of the Employment (as % of total employment) in Self-employed in 1993 to that in 1994?
Keep it short and to the point. 1.12. What is the ratio of the Employment (as % of total employment) in Agriculture in 1993 to that in 1995?
Offer a very short reply. 1.06. What is the ratio of the Employment (as % of total employment) of Industry in 1993 to that in 1995?
Keep it short and to the point. 0.96. What is the ratio of the Employment (as % of total employment) of Self-employed in 1993 to that in 1995?
Provide a short and direct response. 1.13. What is the ratio of the Employment (as % of total employment) in Agriculture in 1993 to that in 1996?
Offer a terse response. 1.09. What is the ratio of the Employment (as % of total employment) in Industry in 1993 to that in 1996?
Your response must be concise. 0.95. What is the ratio of the Employment (as % of total employment) in Services in 1993 to that in 1996?
Your answer should be very brief. 0.99. What is the ratio of the Employment (as % of total employment) of Self-employed in 1993 to that in 1996?
Offer a terse response. 1.17. What is the ratio of the Employment (as % of total employment) in Agriculture in 1993 to that in 1997?
Your answer should be very brief. 1.06. What is the ratio of the Employment (as % of total employment) of Services in 1993 to that in 1997?
Give a very brief answer. 0.99. What is the ratio of the Employment (as % of total employment) in Self-employed in 1993 to that in 1997?
Your answer should be compact. 1.16. What is the ratio of the Employment (as % of total employment) in Agriculture in 1993 to that in 1998?
Provide a short and direct response. 1.22. What is the ratio of the Employment (as % of total employment) in Industry in 1993 to that in 1998?
Provide a short and direct response. 0.96. What is the ratio of the Employment (as % of total employment) in Services in 1993 to that in 1998?
Ensure brevity in your answer.  0.96. What is the ratio of the Employment (as % of total employment) of Self-employed in 1993 to that in 1998?
Offer a terse response. 1.18. What is the ratio of the Employment (as % of total employment) of Agriculture in 1994 to that in 1995?
Offer a very short reply. 1.04. What is the ratio of the Employment (as % of total employment) in Industry in 1994 to that in 1995?
Your answer should be very brief. 0.95. What is the ratio of the Employment (as % of total employment) in Self-employed in 1994 to that in 1995?
Keep it short and to the point. 1.01. What is the ratio of the Employment (as % of total employment) in Agriculture in 1994 to that in 1996?
Make the answer very short. 1.08. What is the ratio of the Employment (as % of total employment) of Industry in 1994 to that in 1996?
Your answer should be very brief. 0.94. What is the ratio of the Employment (as % of total employment) in Self-employed in 1994 to that in 1996?
Provide a short and direct response. 1.04. What is the ratio of the Employment (as % of total employment) in Agriculture in 1994 to that in 1997?
Your answer should be very brief. 1.05. What is the ratio of the Employment (as % of total employment) of Industry in 1994 to that in 1997?
Keep it short and to the point. 0.96. What is the ratio of the Employment (as % of total employment) in Services in 1994 to that in 1997?
Your answer should be very brief. 0.99. What is the ratio of the Employment (as % of total employment) in Self-employed in 1994 to that in 1997?
Keep it short and to the point. 1.04. What is the ratio of the Employment (as % of total employment) in Agriculture in 1994 to that in 1998?
Make the answer very short. 1.2. What is the ratio of the Employment (as % of total employment) in Industry in 1994 to that in 1998?
Your answer should be very brief. 0.94. What is the ratio of the Employment (as % of total employment) in Services in 1994 to that in 1998?
Ensure brevity in your answer.  0.96. What is the ratio of the Employment (as % of total employment) in Self-employed in 1994 to that in 1998?
Ensure brevity in your answer.  1.05. What is the ratio of the Employment (as % of total employment) of Agriculture in 1995 to that in 1996?
Offer a very short reply. 1.03. What is the ratio of the Employment (as % of total employment) in Self-employed in 1995 to that in 1996?
Offer a terse response. 1.03. What is the ratio of the Employment (as % of total employment) of Agriculture in 1995 to that in 1997?
Your answer should be very brief. 1. What is the ratio of the Employment (as % of total employment) of Industry in 1995 to that in 1997?
Keep it short and to the point. 1.01. What is the ratio of the Employment (as % of total employment) in Self-employed in 1995 to that in 1997?
Your answer should be compact. 1.03. What is the ratio of the Employment (as % of total employment) of Agriculture in 1995 to that in 1998?
Your answer should be compact. 1.15. What is the ratio of the Employment (as % of total employment) of Services in 1995 to that in 1998?
Your response must be concise. 0.97. What is the ratio of the Employment (as % of total employment) of Self-employed in 1995 to that in 1998?
Offer a very short reply. 1.04. What is the ratio of the Employment (as % of total employment) of Industry in 1996 to that in 1997?
Offer a terse response. 1.02. What is the ratio of the Employment (as % of total employment) in Services in 1996 to that in 1997?
Provide a short and direct response. 1. What is the ratio of the Employment (as % of total employment) of Agriculture in 1996 to that in 1998?
Offer a terse response. 1.11. What is the ratio of the Employment (as % of total employment) of Industry in 1996 to that in 1998?
Provide a succinct answer. 1. What is the ratio of the Employment (as % of total employment) of Services in 1996 to that in 1998?
Provide a succinct answer. 0.97. What is the ratio of the Employment (as % of total employment) in Self-employed in 1996 to that in 1998?
Make the answer very short. 1.01. What is the ratio of the Employment (as % of total employment) in Agriculture in 1997 to that in 1998?
Offer a terse response. 1.15. What is the ratio of the Employment (as % of total employment) of Industry in 1997 to that in 1998?
Keep it short and to the point. 0.98. What is the ratio of the Employment (as % of total employment) in Services in 1997 to that in 1998?
Make the answer very short. 0.97. What is the ratio of the Employment (as % of total employment) in Self-employed in 1997 to that in 1998?
Provide a succinct answer. 1.01. What is the difference between the highest and the second highest Employment (as % of total employment) in Agriculture?
Keep it short and to the point. 1.56. What is the difference between the highest and the second highest Employment (as % of total employment) of Industry?
Offer a terse response. 0.05. What is the difference between the highest and the second highest Employment (as % of total employment) in Services?
Your answer should be compact. 1.85. What is the difference between the highest and the second highest Employment (as % of total employment) of Self-employed?
Your response must be concise. 1.95. What is the difference between the highest and the lowest Employment (as % of total employment) of Agriculture?
Make the answer very short. 4.75. What is the difference between the highest and the lowest Employment (as % of total employment) in Industry?
Offer a terse response. 1.24. What is the difference between the highest and the lowest Employment (as % of total employment) in Services?
Your answer should be very brief. 4.33. What is the difference between the highest and the lowest Employment (as % of total employment) in Self-employed?
Make the answer very short. 5.47. 